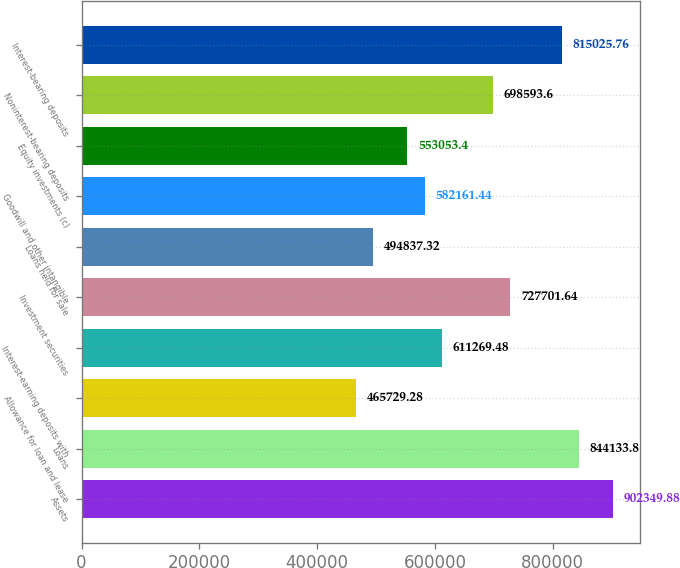Convert chart to OTSL. <chart><loc_0><loc_0><loc_500><loc_500><bar_chart><fcel>Assets<fcel>Loans<fcel>Allowance for loan and lease<fcel>Interest-earning deposits with<fcel>Investment securities<fcel>Loans held for sale<fcel>Goodwill and other intangible<fcel>Equity investments (c)<fcel>Noninterest-bearing deposits<fcel>Interest-bearing deposits<nl><fcel>902350<fcel>844134<fcel>465729<fcel>611269<fcel>727702<fcel>494837<fcel>582161<fcel>553053<fcel>698594<fcel>815026<nl></chart> 